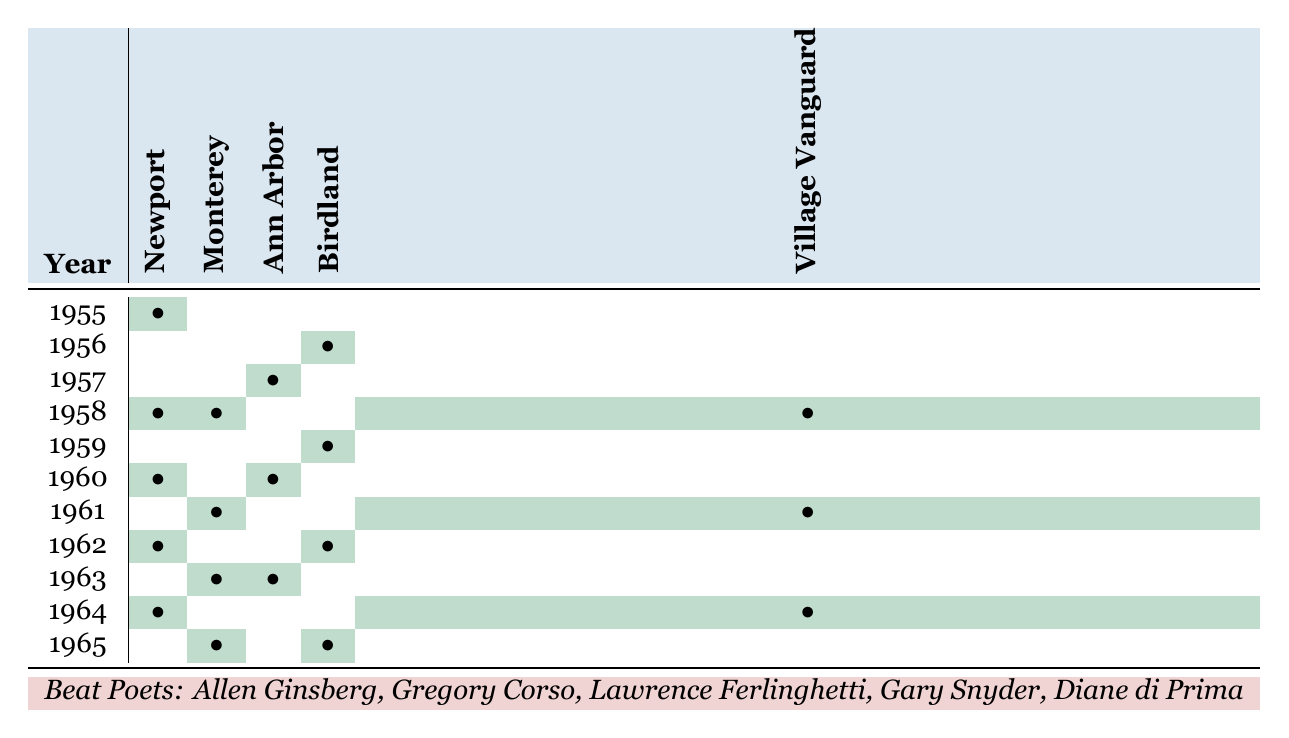What year did Allen Ginsberg perform at the Newport Jazz Festival? Allen Ginsberg performed at the Newport Jazz Festival in the years 1955, 1958, 1960, and 1962 when the cells under Newport for those years are marked.
Answer: 1955, 1958, 1960, 1962 Which poet had the most appearances across all festivals in 1961? By checking the appearances for each poet in 1961, Gregory Corso and Diane di Prima both had one appearance each, while Allen Ginsberg and Gary Snyder had none, and Lawrence Ferlinghetti had one. Thus the maximum appearances is one.
Answer: Gregory Corso or Diane di Prima How many times did Gary Snyder perform at the Birdland Jazz Festival? Looking at the Birdland column, Gary Snyder performed in 1956 and 1965, totaling two performances.
Answer: 2 Did Diane di Prima perform at the Village Vanguard in 1965? There is a checkmark in the Village Vanguard column for the year 1965 under Diane di Prima, confirming that she performed there.
Answer: Yes What is the total number of appearances by all poets at the Monterey Jazz Festival from 1955 to 1965? By summing the appearances at the Monterey column: 0 (1955) + 0 (1956) + 0 (1957) + 1 (1958) + 0 (1959) + 0 (1960) + 1 (1961) + 0 (1962) + 1 (1963) + 0 (1964) + 1 (1965) = 4.
Answer: 4 In which year did both Allen Ginsberg and Lawrence Ferlinghetti perform at the same festival? By examining the table, both Allen Ginsberg and Lawrence Ferlinghetti performed together at the Newport Jazz Festival in 1958.
Answer: 1958 How many total performances did the beat poets have at the Ann Arbor Jazz Festival? Checking the Ann Arbor column, there were performances in 1957 (1), and 1963 (1), totaling 2 performances.
Answer: 2 Which festival had the highest total number of appearances by beat poets across all years? Calculating appearances by summing each column: Newport (5), Monterey (4), Ann Arbor (2), Birdland (3), Village Vanguard (3). Newport has the highest total.
Answer: Newport Jazz Festival What was the least attended festival by beat poets overall, in terms of total appearances? Adding the performances for each festival: Newport 5, Monterey 4, Ann Arbor 2, Birdland 3, Village Vanguard 3. The Ann Arbor Jazz Festival has the least total appearances with 2.
Answer: Ann Arbor Jazz Festival Did Gregory Corso perform more than once at any festival? Looking at the individual counts for Gregory Corso across all festivals, he performed only once at the Newport in 1961, then once at Birdland in 1956. No other festivals have more than one performance, confirming he did not perform more than once.
Answer: No 